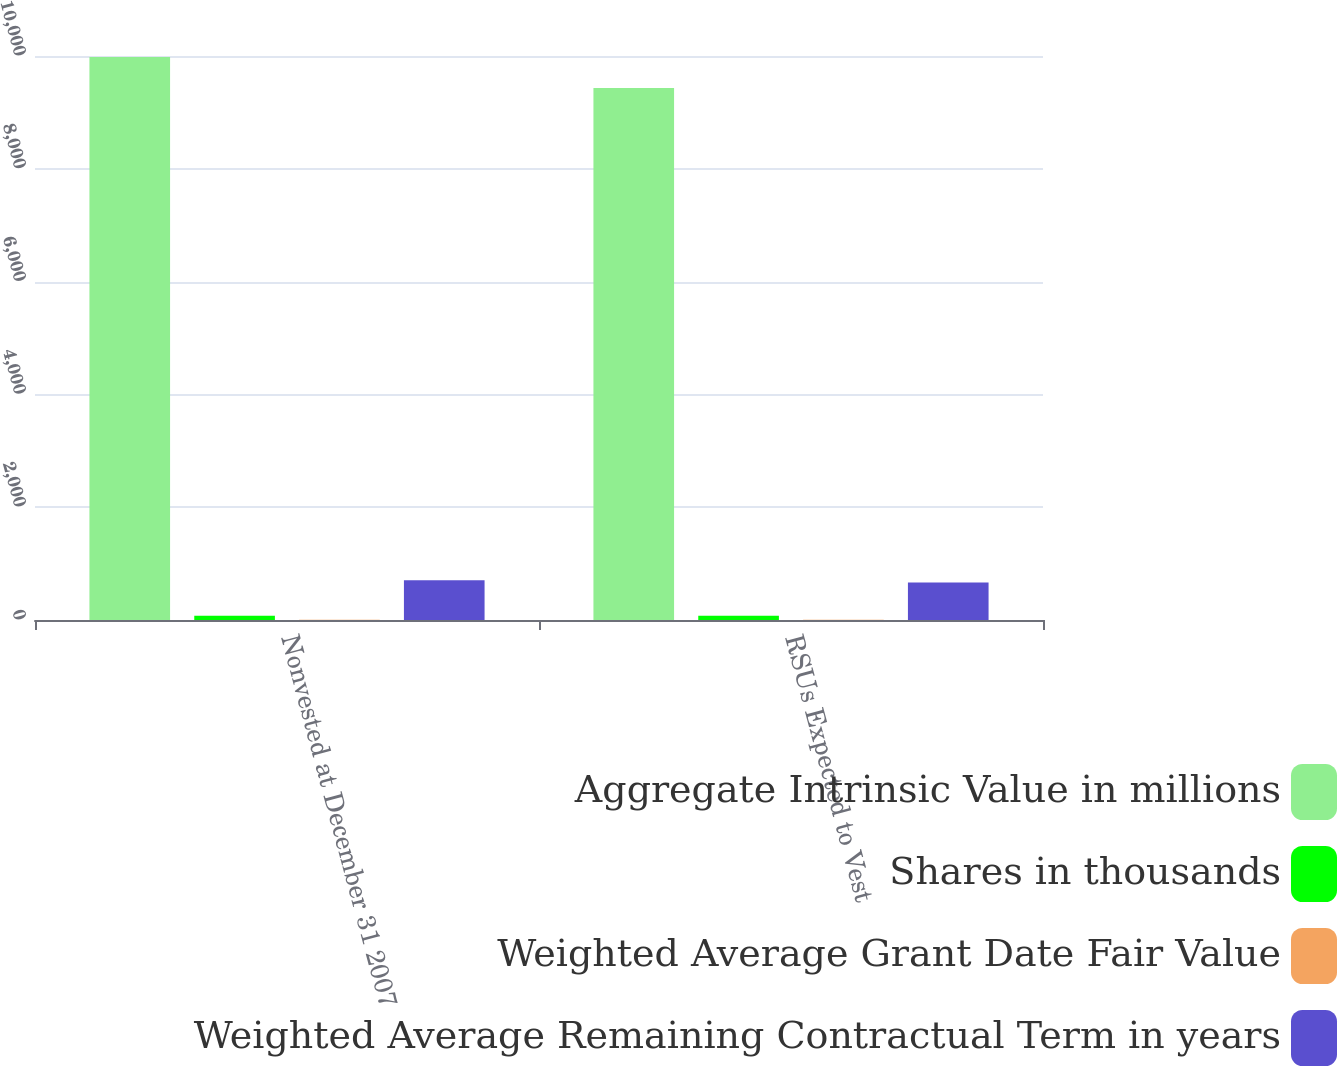Convert chart. <chart><loc_0><loc_0><loc_500><loc_500><stacked_bar_chart><ecel><fcel>Nonvested at December 31 2007<fcel>RSUs Expected to Vest<nl><fcel>Aggregate Intrinsic Value in millions<fcel>9982<fcel>9431<nl><fcel>Shares in thousands<fcel>74.34<fcel>74.31<nl><fcel>Weighted Average Grant Date Fair Value<fcel>2.37<fcel>2.31<nl><fcel>Weighted Average Remaining Contractual Term in years<fcel>706<fcel>667<nl></chart> 